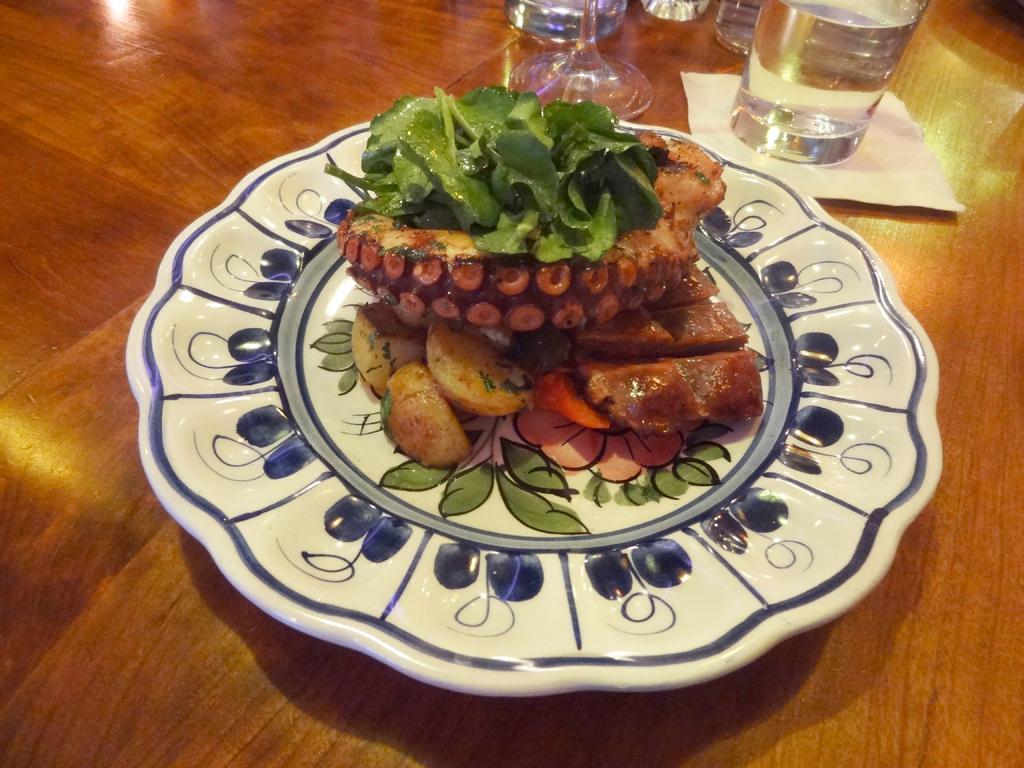Please provide a concise description of this image. This is the wooden table with a glass of water, tissue paper and a plate. This plate contains some food items in it. 